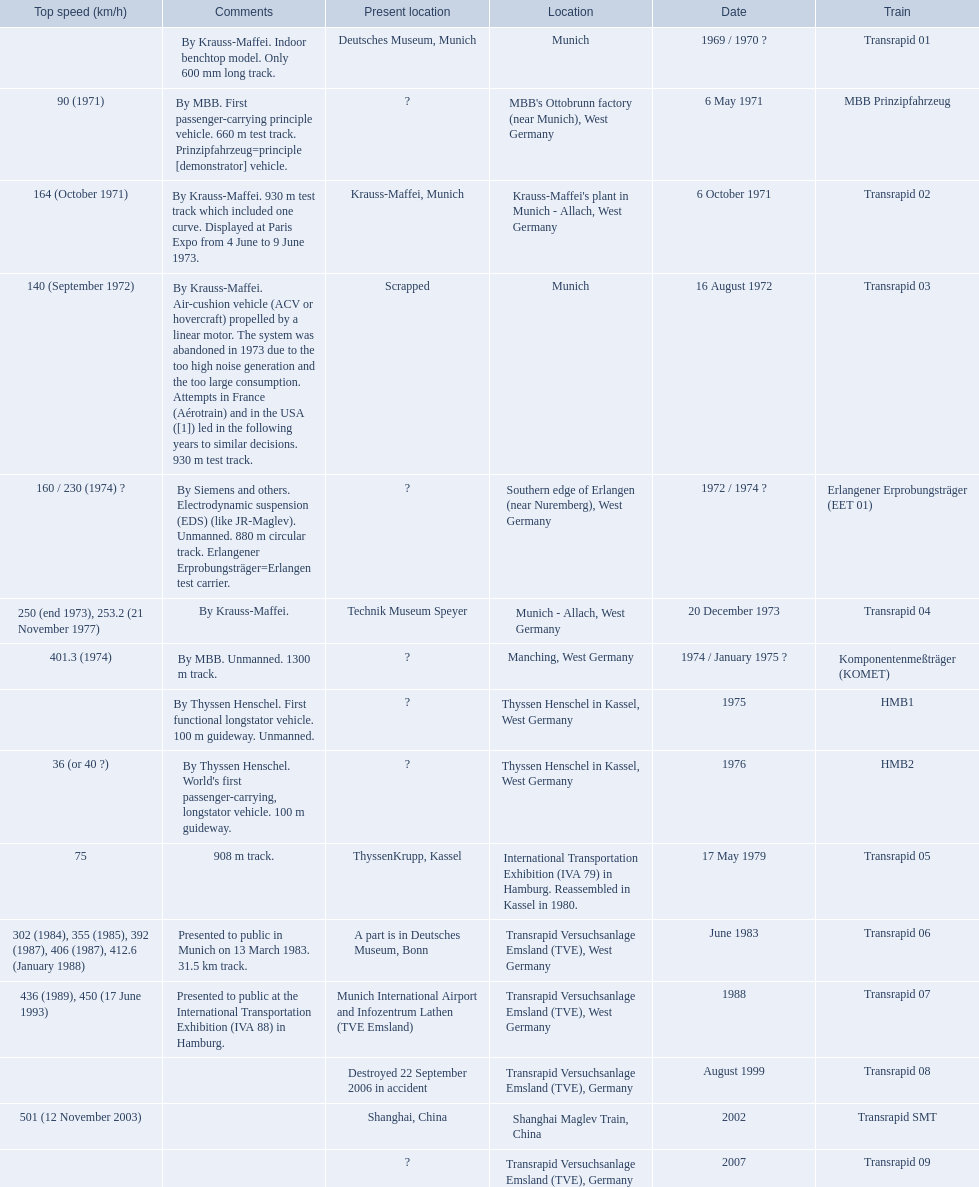What is the top speed reached by any trains shown here? 501 (12 November 2003). What train has reached a top speed of 501? Transrapid SMT. 